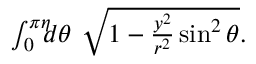<formula> <loc_0><loc_0><loc_500><loc_500>\begin{array} { r } { \int _ { 0 } ^ { \pi \eta } \, d \theta \ \sqrt { 1 - \frac { y ^ { 2 } } { r ^ { 2 } } \sin ^ { 2 } \theta } . } \end{array}</formula> 